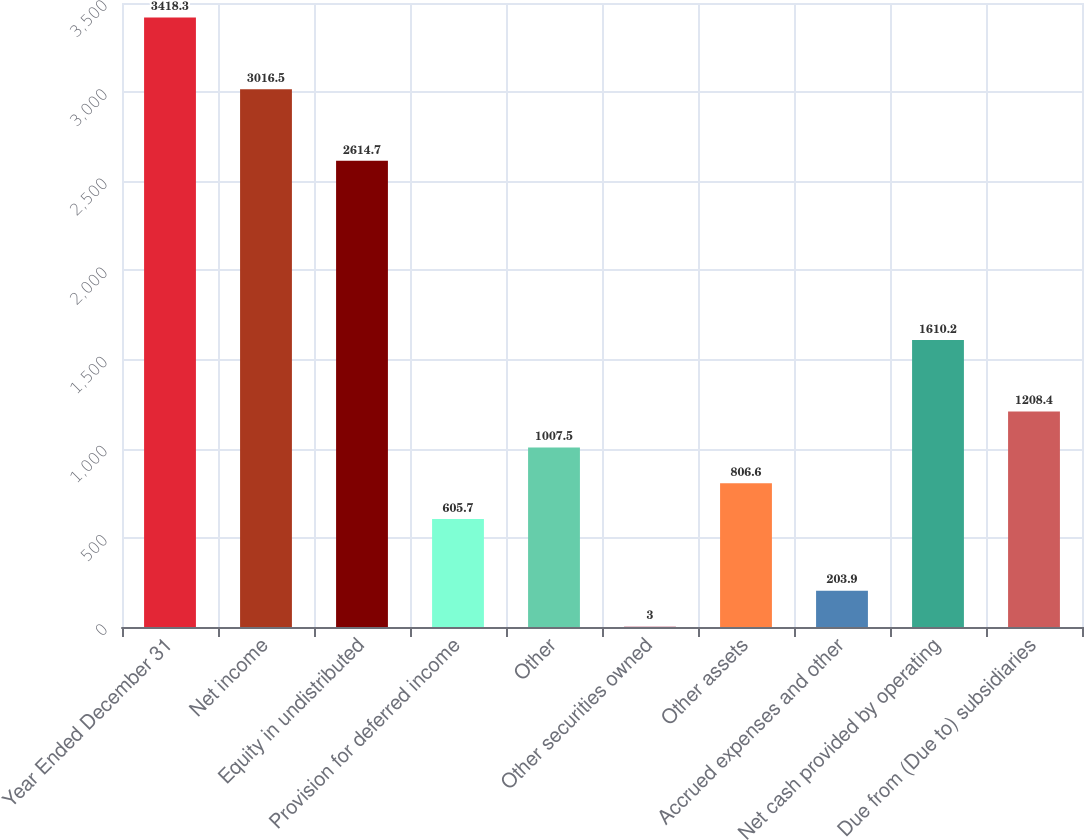Convert chart. <chart><loc_0><loc_0><loc_500><loc_500><bar_chart><fcel>Year Ended December 31<fcel>Net income<fcel>Equity in undistributed<fcel>Provision for deferred income<fcel>Other<fcel>Other securities owned<fcel>Other assets<fcel>Accrued expenses and other<fcel>Net cash provided by operating<fcel>Due from (Due to) subsidiaries<nl><fcel>3418.3<fcel>3016.5<fcel>2614.7<fcel>605.7<fcel>1007.5<fcel>3<fcel>806.6<fcel>203.9<fcel>1610.2<fcel>1208.4<nl></chart> 